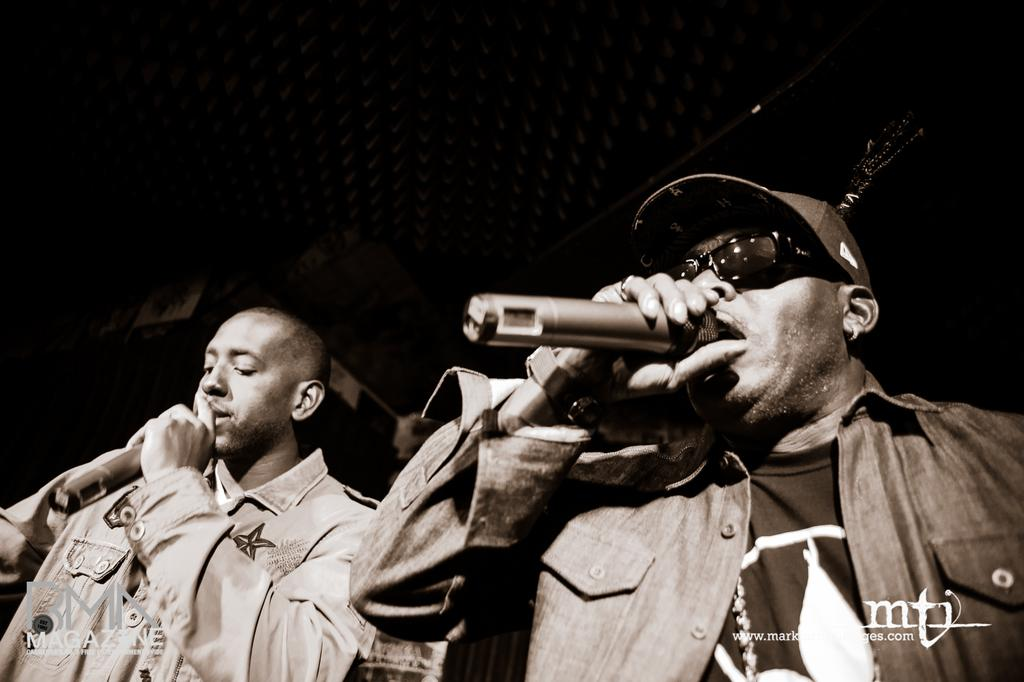How many people are in the image? There are two people in the image. What can be seen in the image that is related to communication? There is a microphone in the image. What is the person on the right side wearing on their head? The person on the right side is wearing a cap. What type of eyewear is the person on the right side wearing? The person on the right side is wearing goggles. What type of wine is being served in the image? There is no wine present in the image. What letters can be seen on the microphone in the image? The image does not show any letters on the microphone. 